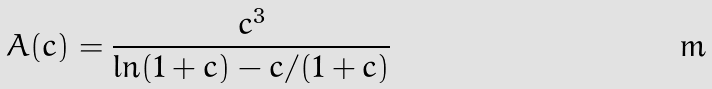<formula> <loc_0><loc_0><loc_500><loc_500>A ( c ) = \frac { c ^ { 3 } } { \ln ( 1 + c ) - c / ( 1 + c ) }</formula> 